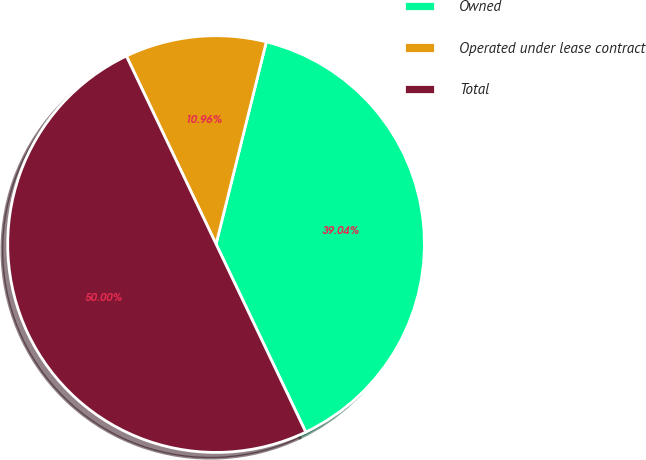Convert chart to OTSL. <chart><loc_0><loc_0><loc_500><loc_500><pie_chart><fcel>Owned<fcel>Operated under lease contract<fcel>Total<nl><fcel>39.04%<fcel>10.96%<fcel>50.0%<nl></chart> 